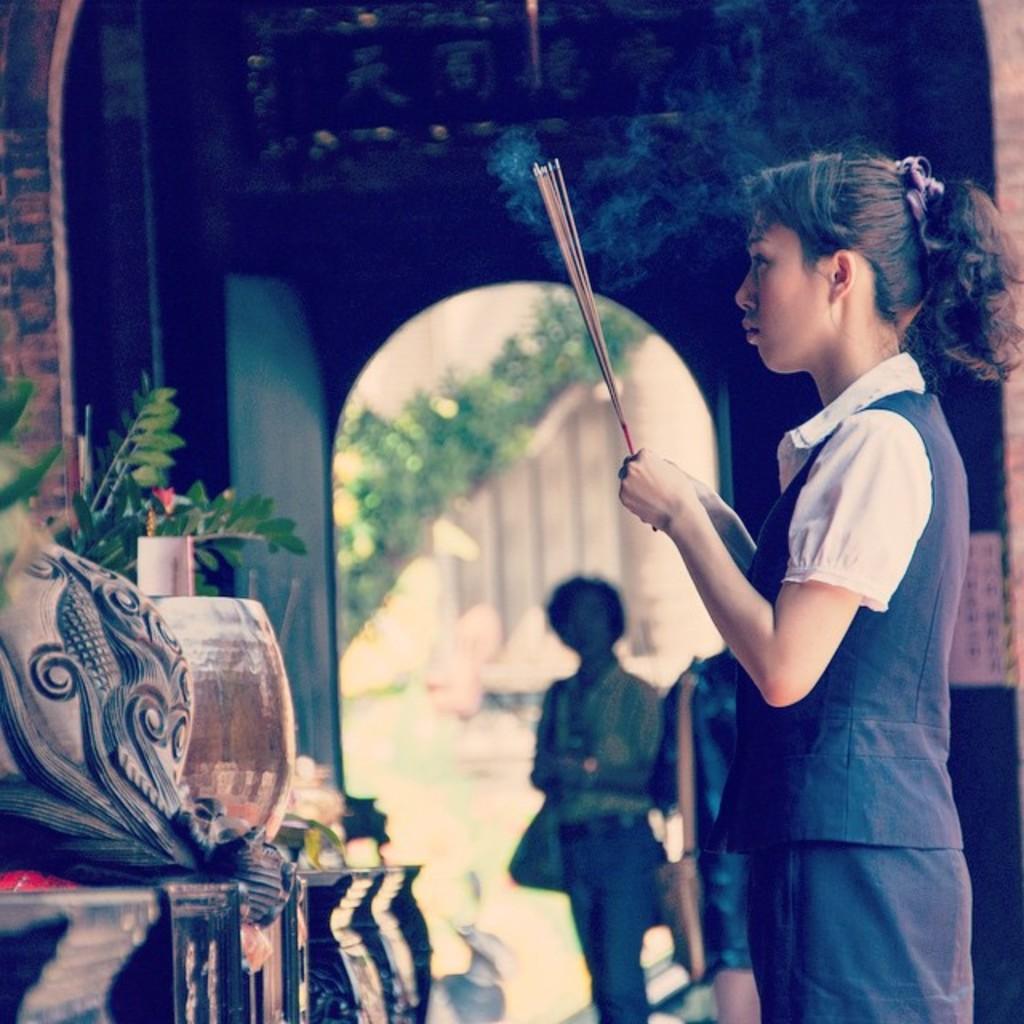Please provide a concise description of this image. On the right side of this image there is a woman standing facing towards the left side and she is holding incense sticks. On the left side there is a table on which few objects are placed and also I can see the leaves of a plant. In the background, I can see the part of a building and also there are two persons standing. 